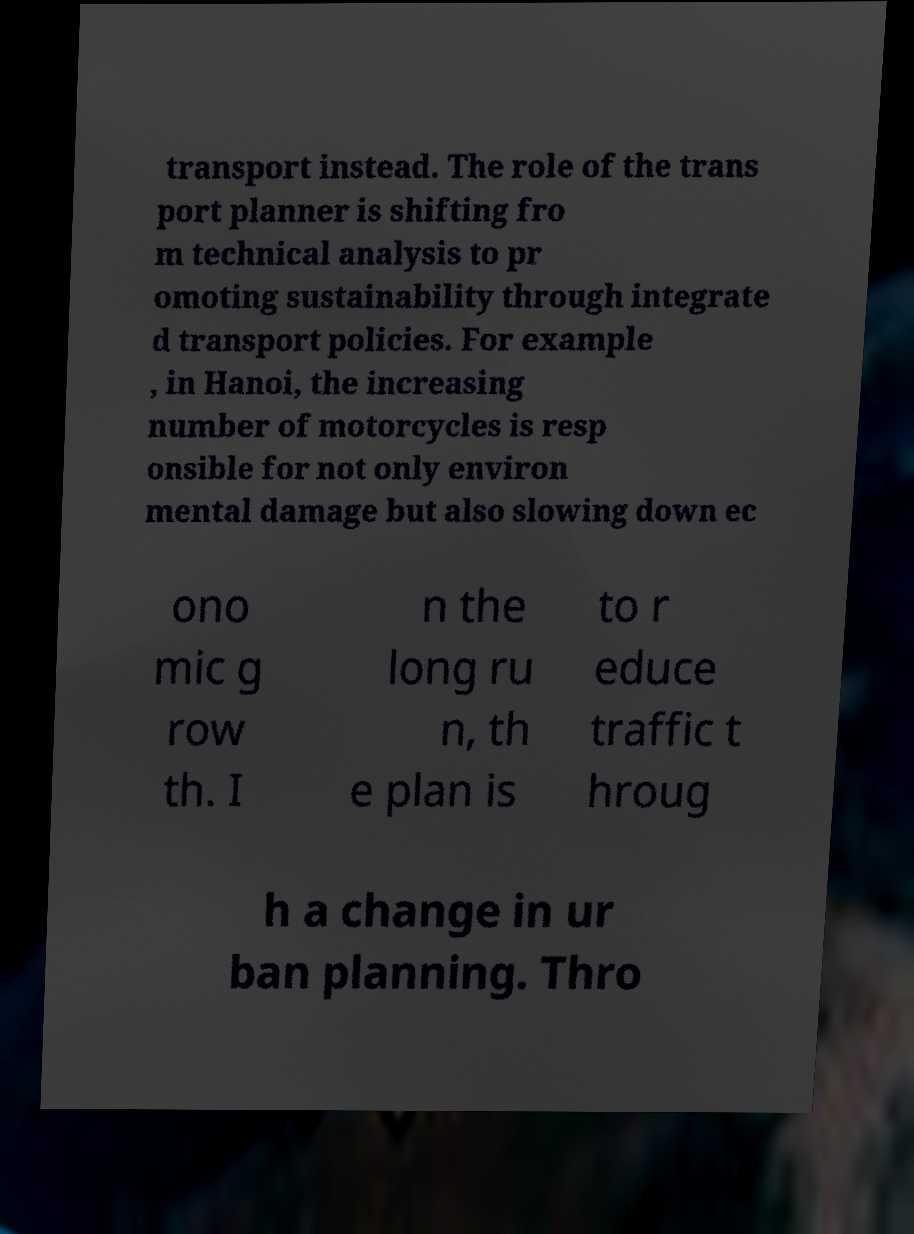I need the written content from this picture converted into text. Can you do that? transport instead. The role of the trans port planner is shifting fro m technical analysis to pr omoting sustainability through integrate d transport policies. For example , in Hanoi, the increasing number of motorcycles is resp onsible for not only environ mental damage but also slowing down ec ono mic g row th. I n the long ru n, th e plan is to r educe traffic t hroug h a change in ur ban planning. Thro 